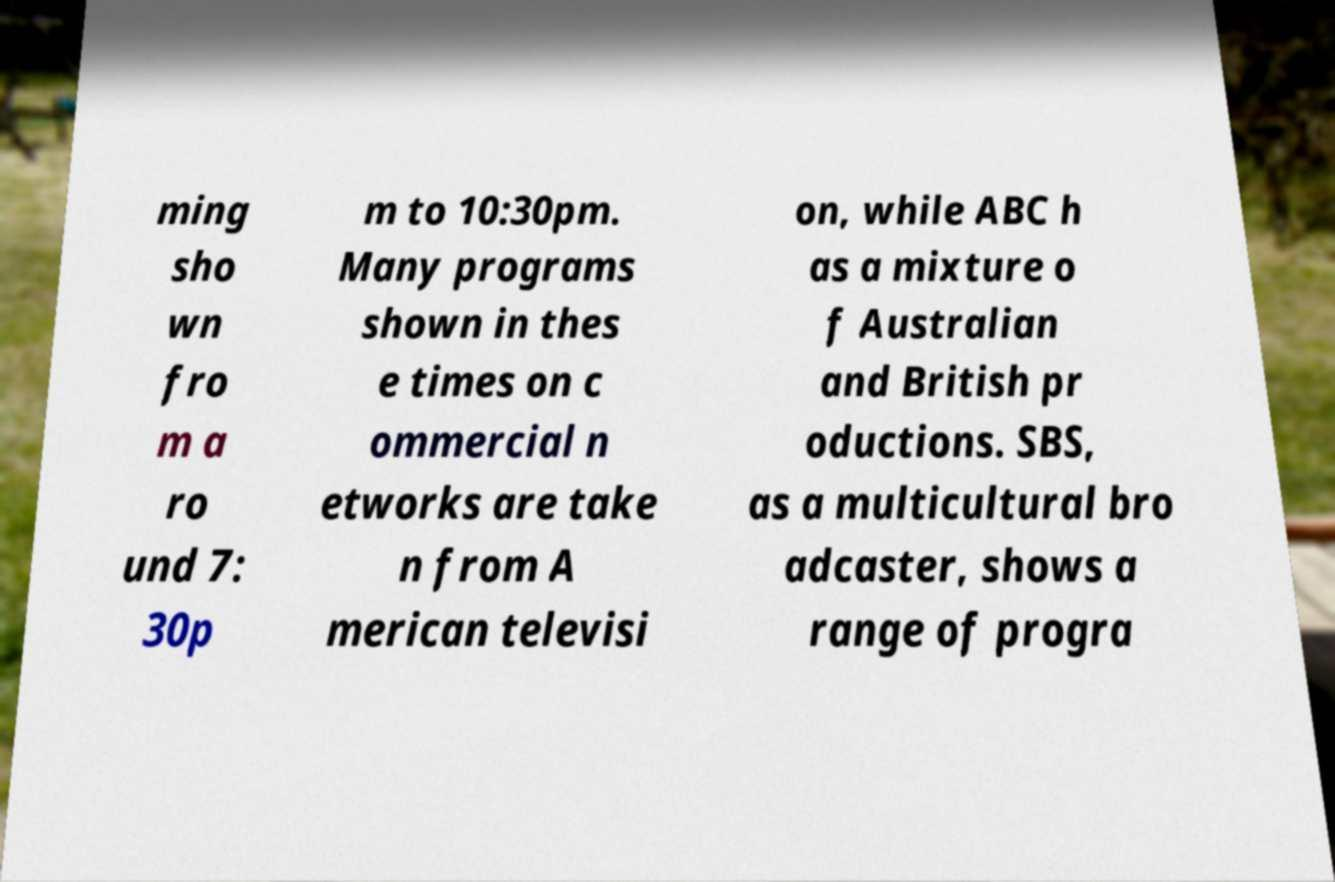Please read and relay the text visible in this image. What does it say? ming sho wn fro m a ro und 7: 30p m to 10:30pm. Many programs shown in thes e times on c ommercial n etworks are take n from A merican televisi on, while ABC h as a mixture o f Australian and British pr oductions. SBS, as a multicultural bro adcaster, shows a range of progra 